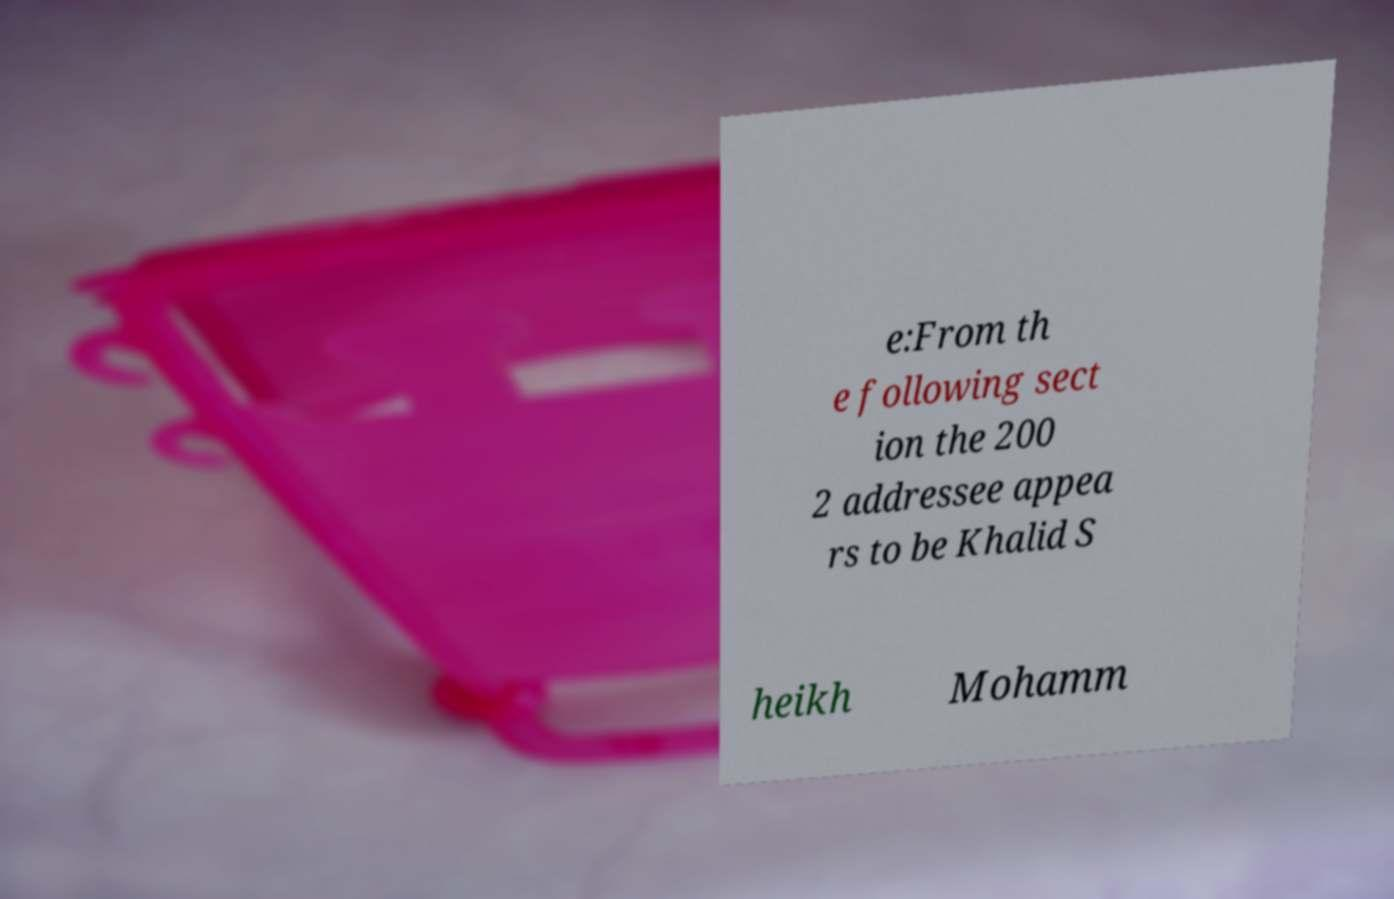Can you read and provide the text displayed in the image?This photo seems to have some interesting text. Can you extract and type it out for me? e:From th e following sect ion the 200 2 addressee appea rs to be Khalid S heikh Mohamm 